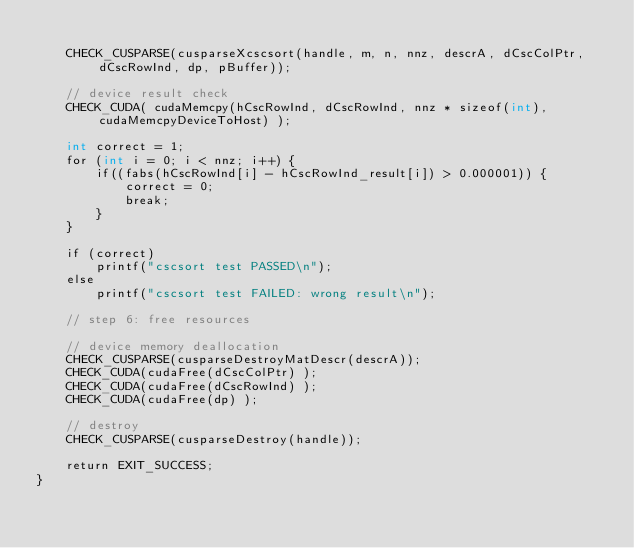<code> <loc_0><loc_0><loc_500><loc_500><_Cuda_>
    CHECK_CUSPARSE(cusparseXcscsort(handle, m, n, nnz, descrA, dCscColPtr, dCscRowInd, dp, pBuffer));

    // device result check
    CHECK_CUDA( cudaMemcpy(hCscRowInd, dCscRowInd, nnz * sizeof(int), cudaMemcpyDeviceToHost) );

    int correct = 1;
    for (int i = 0; i < nnz; i++) {
        if((fabs(hCscRowInd[i] - hCscRowInd_result[i]) > 0.000001)) {
            correct = 0;
            break;
        }
    }

    if (correct)
        printf("cscsort test PASSED\n");
    else
        printf("cscsort test FAILED: wrong result\n");

    // step 6: free resources

    // device memory deallocation
    CHECK_CUSPARSE(cusparseDestroyMatDescr(descrA));
    CHECK_CUDA(cudaFree(dCscColPtr) );
    CHECK_CUDA(cudaFree(dCscRowInd) );
    CHECK_CUDA(cudaFree(dp) );

    // destroy
    CHECK_CUSPARSE(cusparseDestroy(handle));

    return EXIT_SUCCESS;
}</code> 